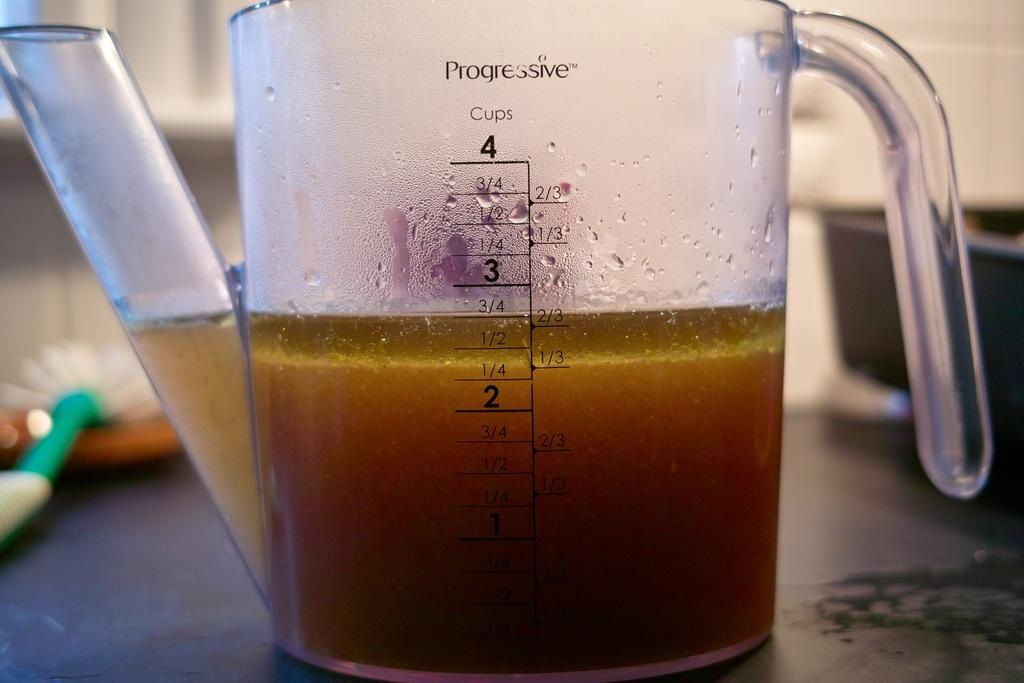What object is present in the image that contains a drink? There is a jar in the image that contains a drink. Where is the jar located in the image? The jar is placed on the floor. What type of lamp is being used by the writer in the image? There is no writer or lamp present in the image; it only features a jar containing a drink and its location on the floor. 